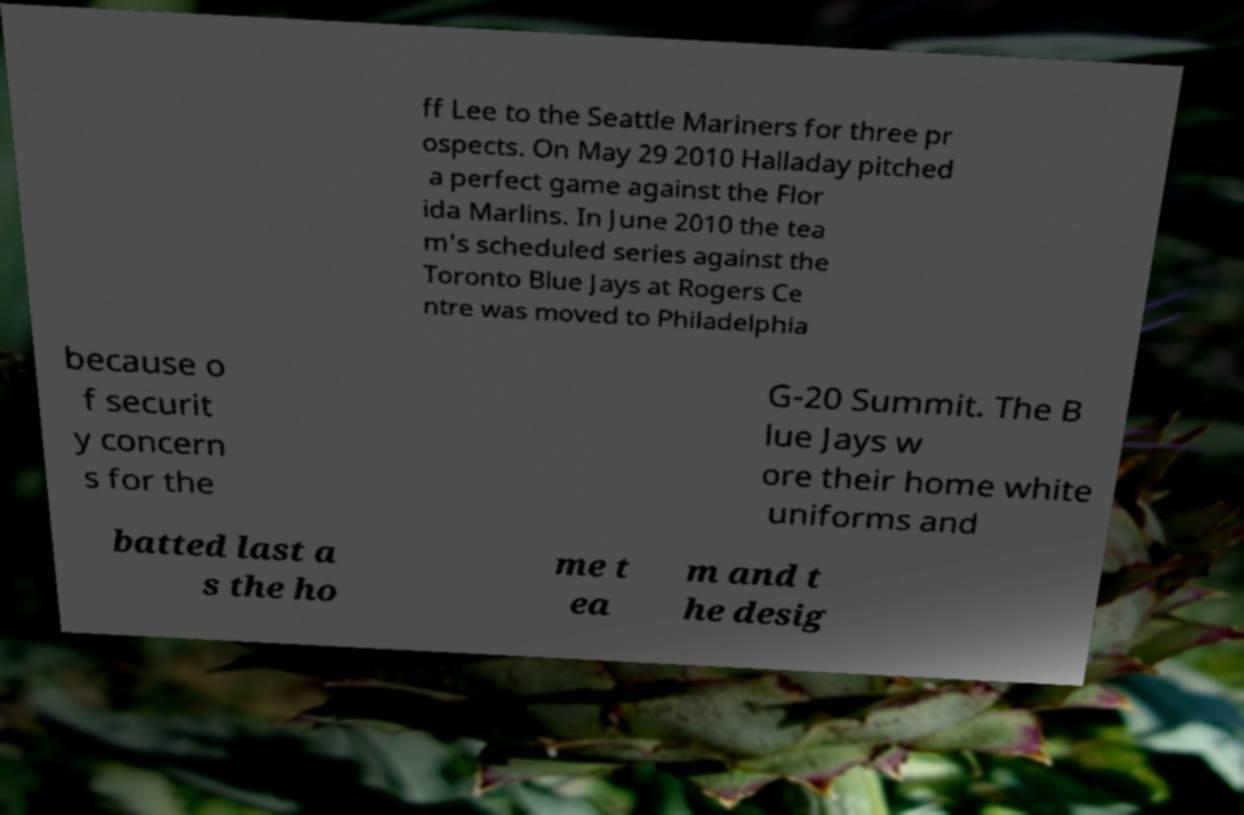There's text embedded in this image that I need extracted. Can you transcribe it verbatim? ff Lee to the Seattle Mariners for three pr ospects. On May 29 2010 Halladay pitched a perfect game against the Flor ida Marlins. In June 2010 the tea m's scheduled series against the Toronto Blue Jays at Rogers Ce ntre was moved to Philadelphia because o f securit y concern s for the G-20 Summit. The B lue Jays w ore their home white uniforms and batted last a s the ho me t ea m and t he desig 